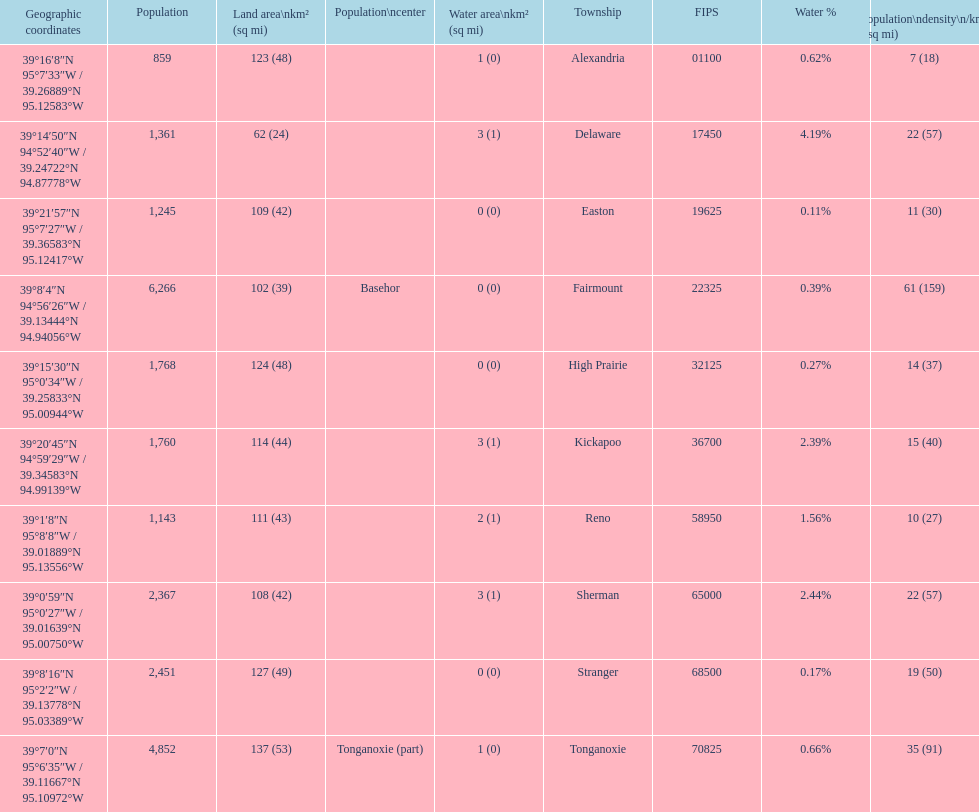Was delaware's land area above or below 45 square miles? Above. 